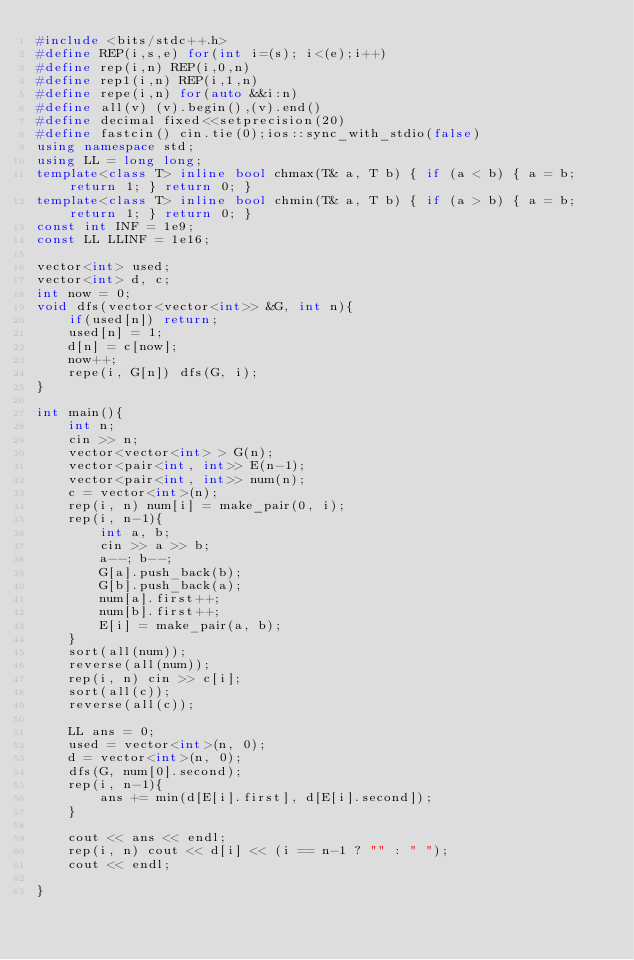Convert code to text. <code><loc_0><loc_0><loc_500><loc_500><_C++_>#include <bits/stdc++.h>
#define REP(i,s,e) for(int i=(s); i<(e);i++)
#define rep(i,n) REP(i,0,n)
#define rep1(i,n) REP(i,1,n)
#define repe(i,n) for(auto &&i:n)
#define all(v) (v).begin(),(v).end()
#define decimal fixed<<setprecision(20)
#define fastcin() cin.tie(0);ios::sync_with_stdio(false)
using namespace std;
using LL = long long;
template<class T> inline bool chmax(T& a, T b) { if (a < b) { a = b; return 1; } return 0; }
template<class T> inline bool chmin(T& a, T b) { if (a > b) { a = b; return 1; } return 0; }
const int INF = 1e9;
const LL LLINF = 1e16;

vector<int> used;
vector<int> d, c;
int now = 0;
void dfs(vector<vector<int>> &G, int n){
    if(used[n]) return;
    used[n] = 1;
    d[n] = c[now];
    now++;
    repe(i, G[n]) dfs(G, i);
}

int main(){
    int n;
    cin >> n;
    vector<vector<int> > G(n);
    vector<pair<int, int>> E(n-1);
    vector<pair<int, int>> num(n);
    c = vector<int>(n);
    rep(i, n) num[i] = make_pair(0, i);
    rep(i, n-1){
        int a, b;
        cin >> a >> b;
        a--; b--;
        G[a].push_back(b);
        G[b].push_back(a);
        num[a].first++;
        num[b].first++;
        E[i] = make_pair(a, b);
    }
    sort(all(num));
    reverse(all(num));
    rep(i, n) cin >> c[i];
    sort(all(c));
    reverse(all(c));

    LL ans = 0;
    used = vector<int>(n, 0);
    d = vector<int>(n, 0);
    dfs(G, num[0].second);
    rep(i, n-1){
        ans += min(d[E[i].first], d[E[i].second]);
    }

    cout << ans << endl;
    rep(i, n) cout << d[i] << (i == n-1 ? "" : " ");
    cout << endl;

}</code> 